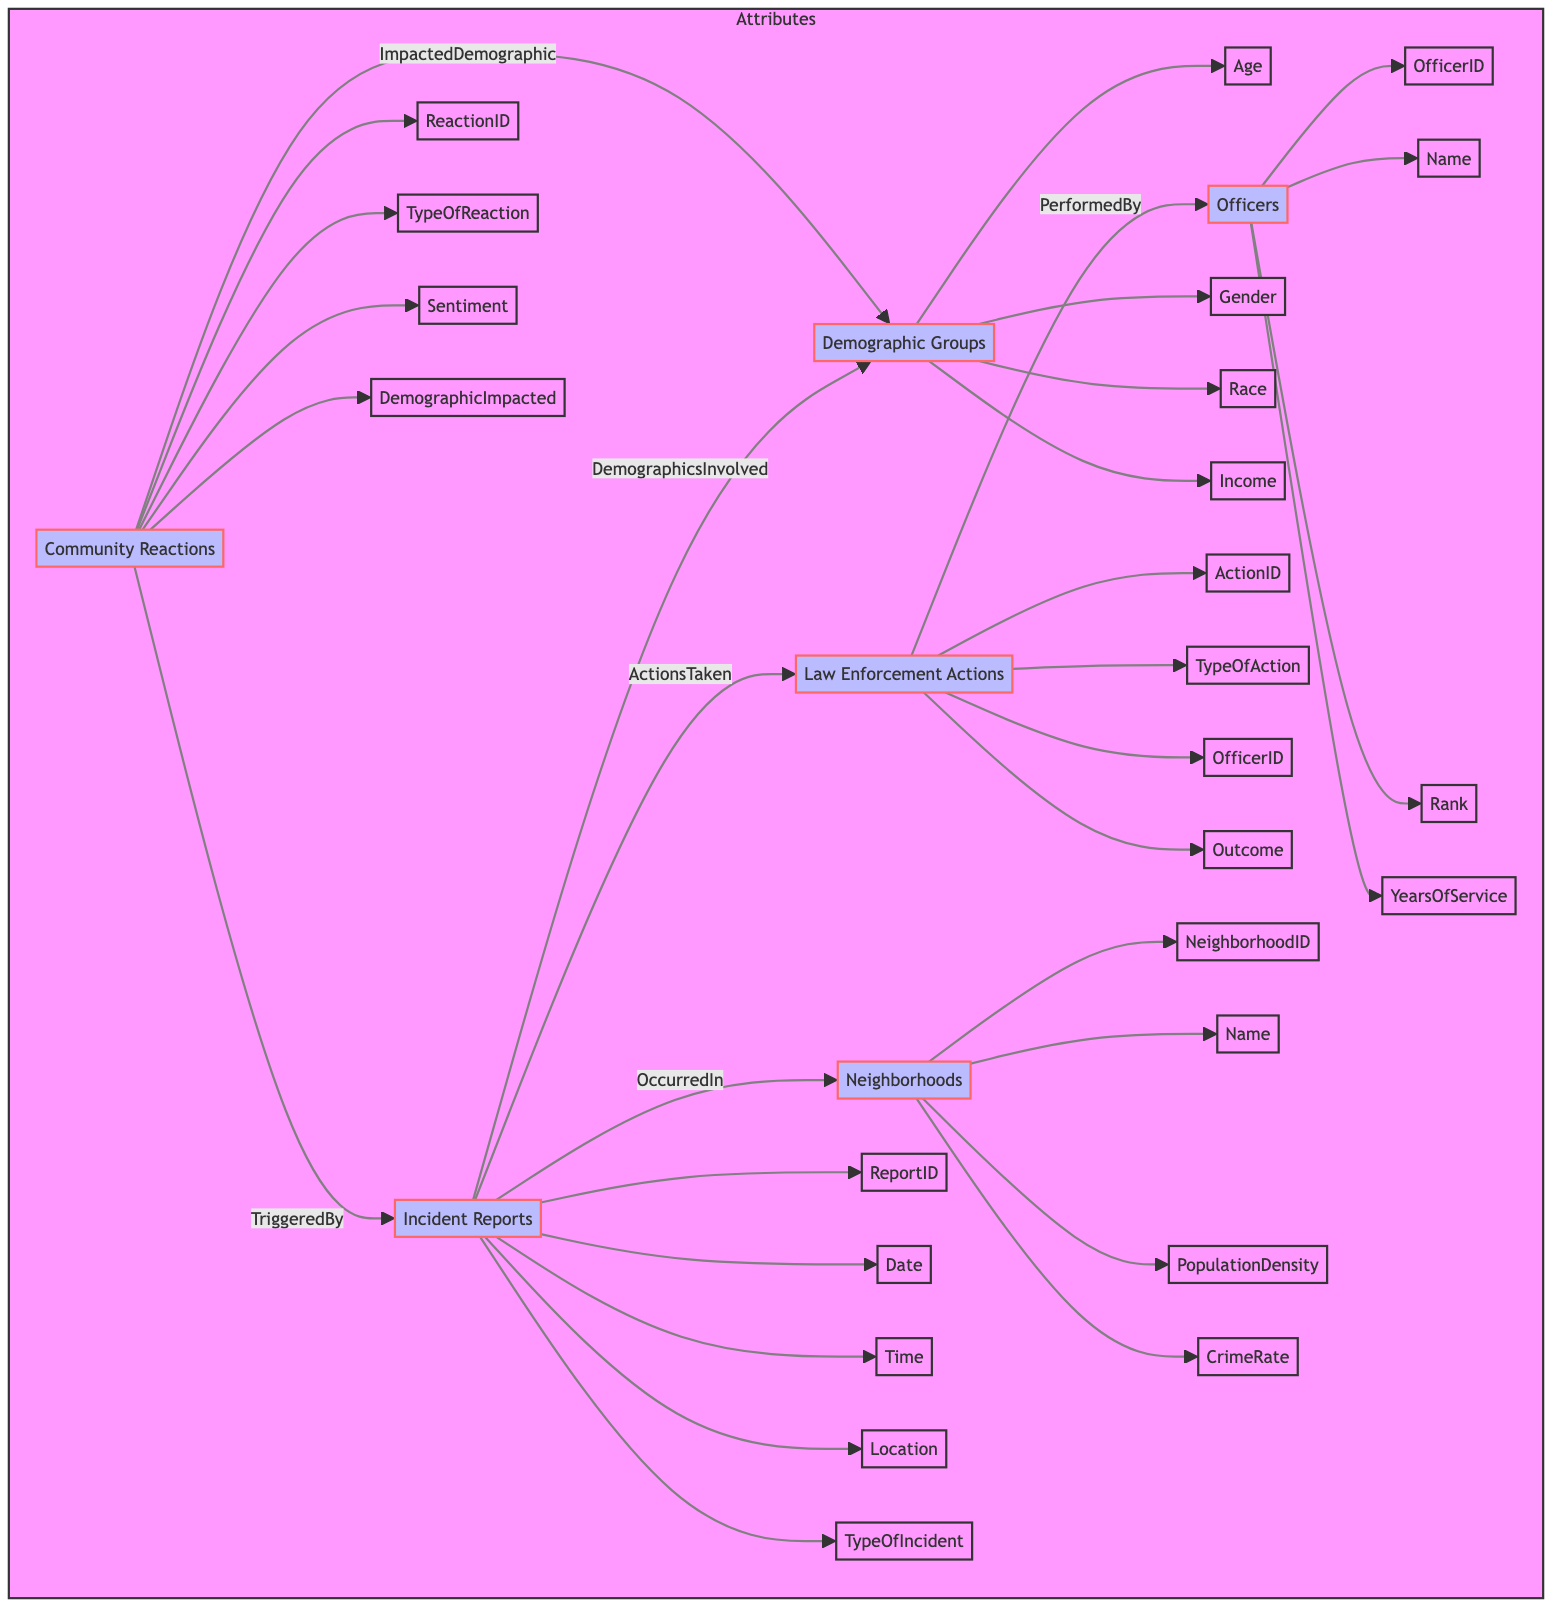What is the main demographic category indicated in the diagram? The main demographic category is "Demographic Groups," which acts as a central node with various attributes and connections to incident reports and community reactions.
Answer: Demographic Groups How many types of law enforcement actions are represented in the diagram? The diagram includes one main node for Law Enforcement Actions, which suggests there are multiple types of actions that can be categorized under it, but it is depicted as a single node without a specified count.
Answer: 1 Which element connects Law Enforcement Actions and Officers? The edge labeled "PerformedBy" connects the Law Enforcement Actions to the Officers, indicating that law enforcement actions are performed by specific officers.
Answer: PerformedBy How many nodes are there in total in the diagram? There are six nodes represented in the diagram: Demographic Groups, Incident Reports, Law Enforcement Actions, Community Reactions, Neighborhoods, and Officers. Counting these nodes gives a total of six.
Answer: 6 What type of investigation primarily triggers community reactions according to the diagram? The edge labeled "TriggeredBy" connects Community Reactions to Incident Reports, suggesting that specific incident reports primarily trigger reactions in the community.
Answer: Incident Reports What is the relationship between Incident Reports and Neighborhoods? The relationship is depicted by the edge labeled "OccurredIn," indicating that incident reports happen within specific neighborhoods.
Answer: OccurredIn Which demographic attributes are influenced by community reactions? The edge labeled "ImpactedDemographic" connects Community Reactions to Demographic Groups, indicating that various demographic attributes are influenced by these reactions, encompassing all listed demographic attributes.
Answer: Demographic Groups Which connection indicates the timeline aspect of incident reports? The attributes of Incident Reports include Date and Time, which denote when each incident occurred and can indicate the timeline of events. The connection is implicit in the incident reports node itself.
Answer: Date, Time How many types of community reactions are represented in the diagram? The Community Reactions node includes various attributes, but the exact number of types is not clear without specific instances; however, the types are represented under the main node as a general category.
Answer: 1 